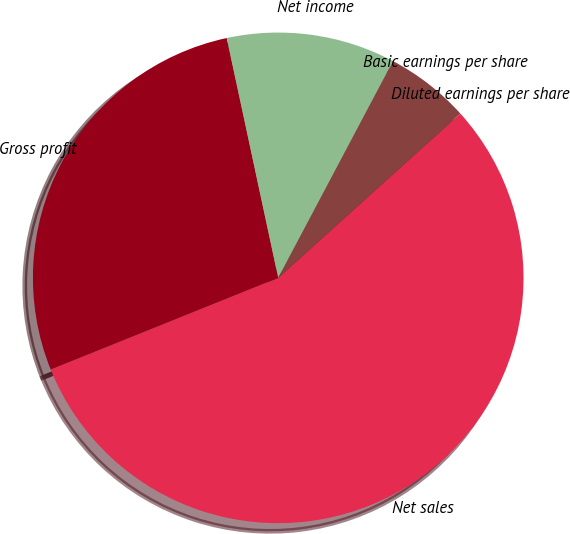<chart> <loc_0><loc_0><loc_500><loc_500><pie_chart><fcel>Net sales<fcel>Gross profit<fcel>Net income<fcel>Basic earnings per share<fcel>Diluted earnings per share<nl><fcel>55.59%<fcel>27.73%<fcel>11.12%<fcel>5.56%<fcel>0.0%<nl></chart> 